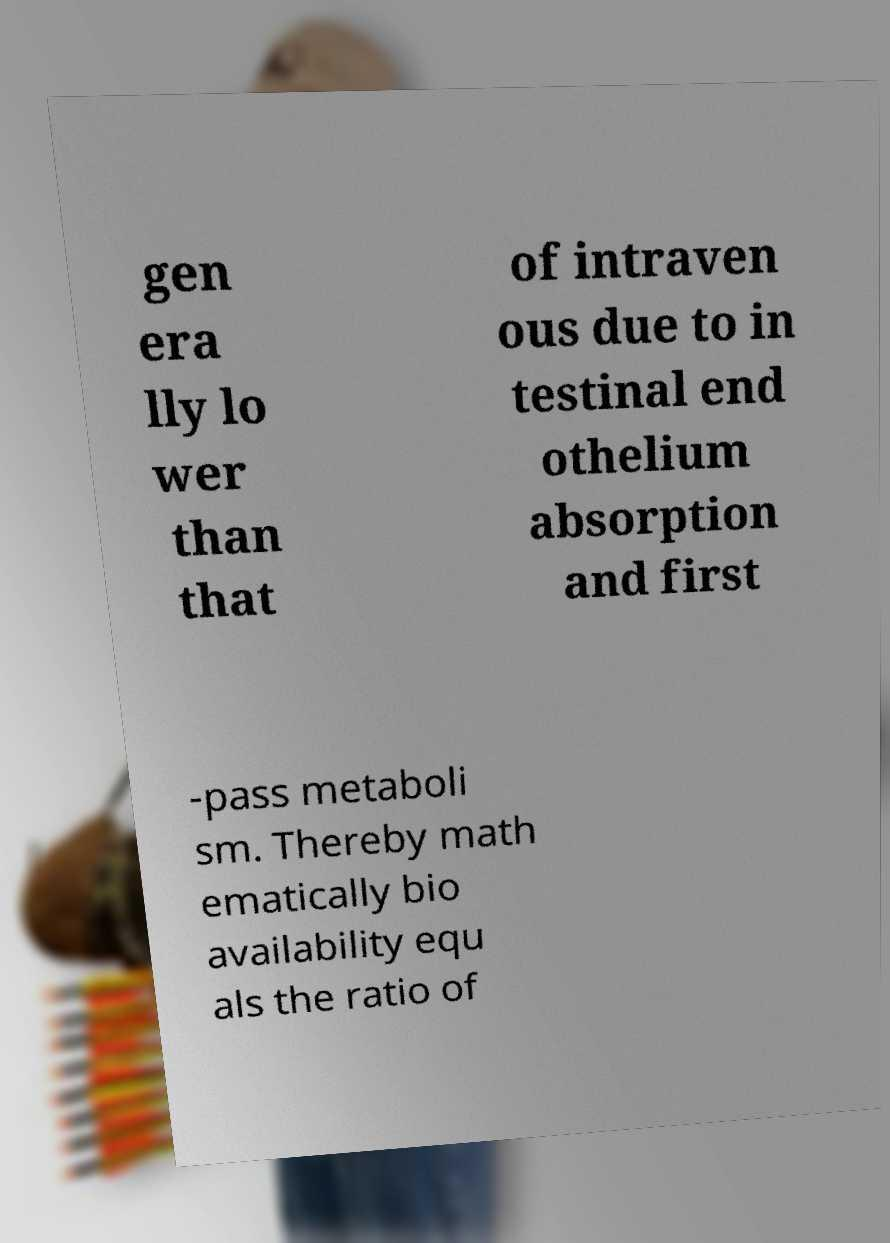There's text embedded in this image that I need extracted. Can you transcribe it verbatim? gen era lly lo wer than that of intraven ous due to in testinal end othelium absorption and first -pass metaboli sm. Thereby math ematically bio availability equ als the ratio of 